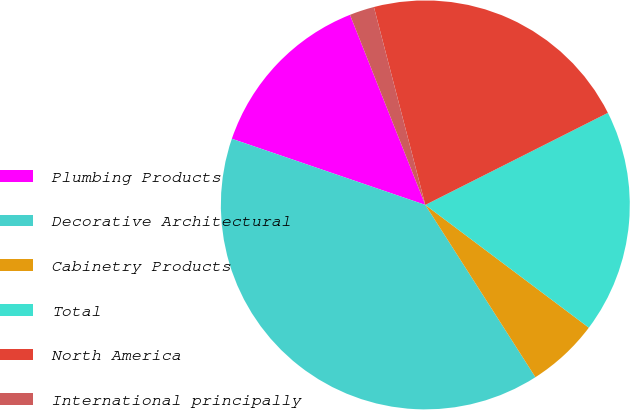Convert chart. <chart><loc_0><loc_0><loc_500><loc_500><pie_chart><fcel>Plumbing Products<fcel>Decorative Architectural<fcel>Cabinetry Products<fcel>Total<fcel>North America<fcel>International principally<nl><fcel>13.75%<fcel>39.29%<fcel>5.7%<fcel>17.68%<fcel>21.61%<fcel>1.96%<nl></chart> 